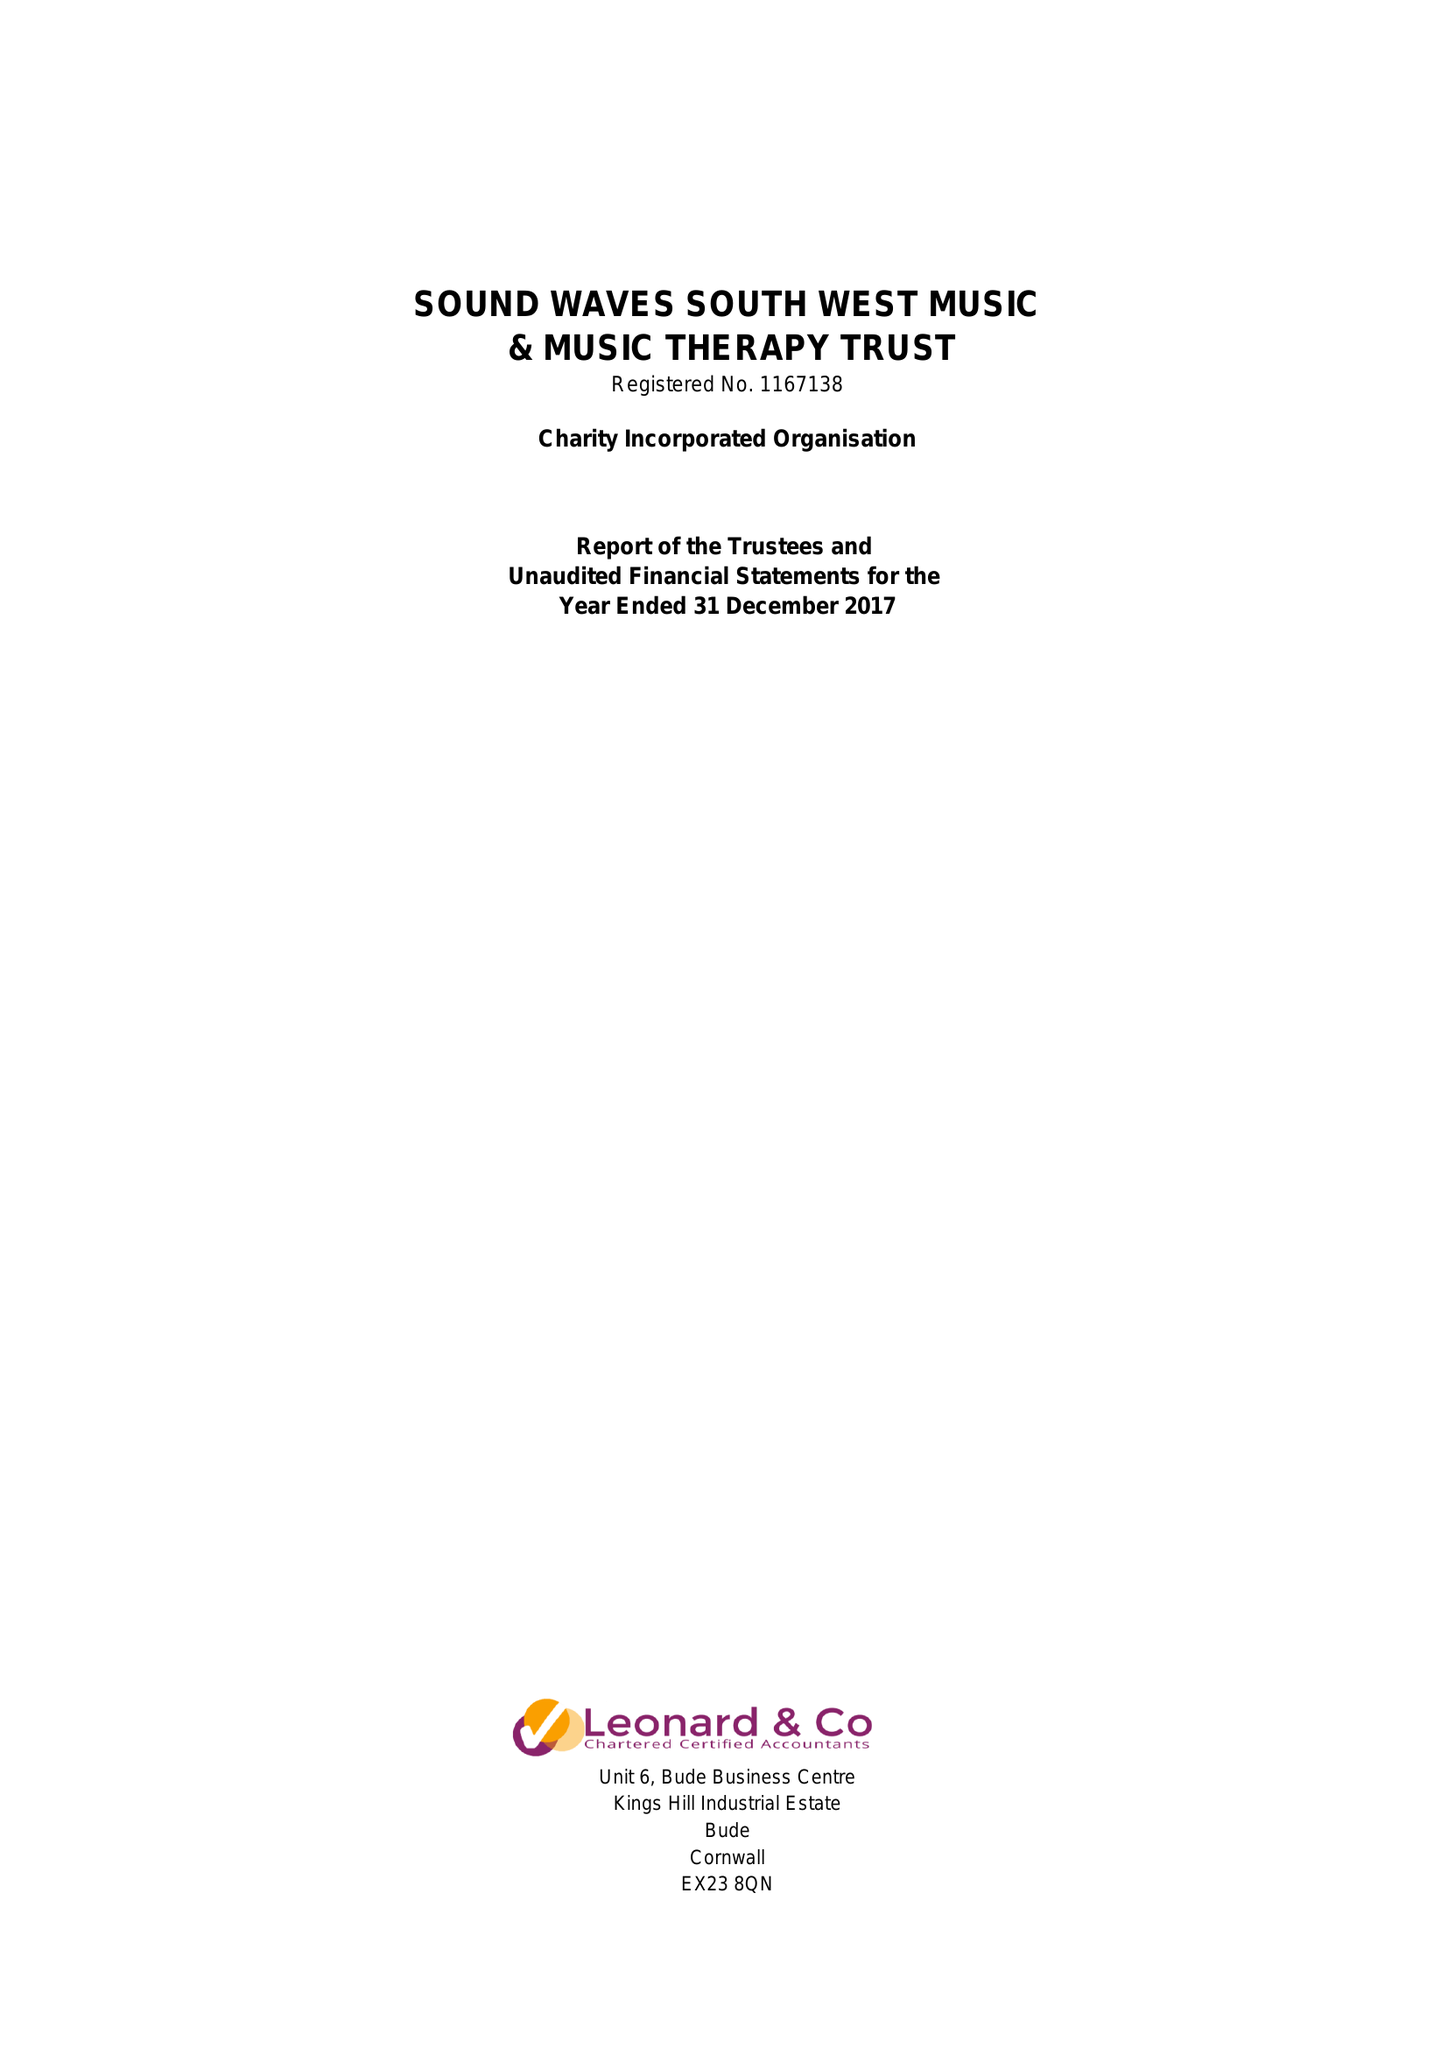What is the value for the spending_annually_in_british_pounds?
Answer the question using a single word or phrase. 28041.00 